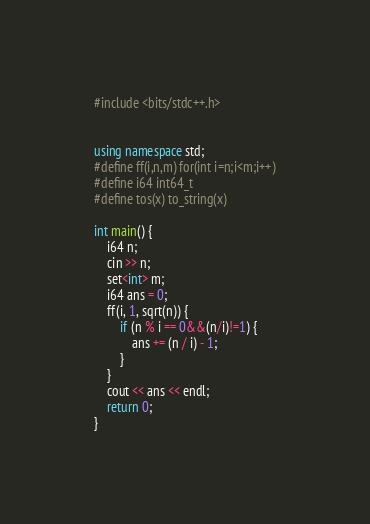Convert code to text. <code><loc_0><loc_0><loc_500><loc_500><_C++_>#include <bits/stdc++.h>


using namespace std;
#define ff(i,n,m) for(int i=n;i<m;i++)
#define i64 int64_t
#define tos(x) to_string(x)

int main() {
	i64 n;
	cin >> n;
	set<int> m;
	i64 ans = 0;
	ff(i, 1, sqrt(n)) {
		if (n % i == 0&&(n/i)!=1) {
			ans += (n / i) - 1;
		}
	}
	cout << ans << endl;
	return 0;
}
</code> 